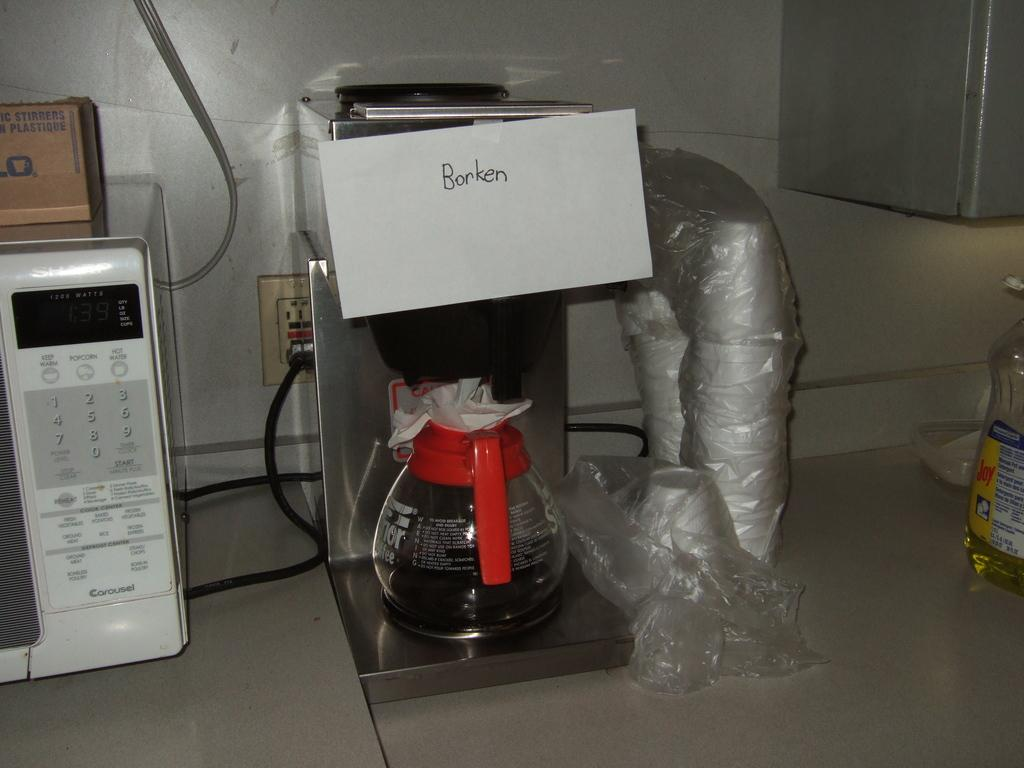<image>
Write a terse but informative summary of the picture. A kitchen counter showing a microwave and a broken coffee pot. 